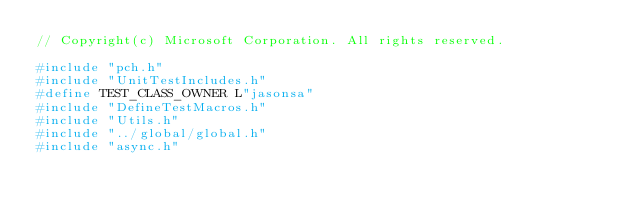<code> <loc_0><loc_0><loc_500><loc_500><_C++_>// Copyright(c) Microsoft Corporation. All rights reserved.

#include "pch.h"
#include "UnitTestIncludes.h"
#define TEST_CLASS_OWNER L"jasonsa"
#include "DefineTestMacros.h"
#include "Utils.h"
#include "../global/global.h"
#include "async.h"</code> 